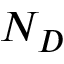<formula> <loc_0><loc_0><loc_500><loc_500>N _ { D }</formula> 